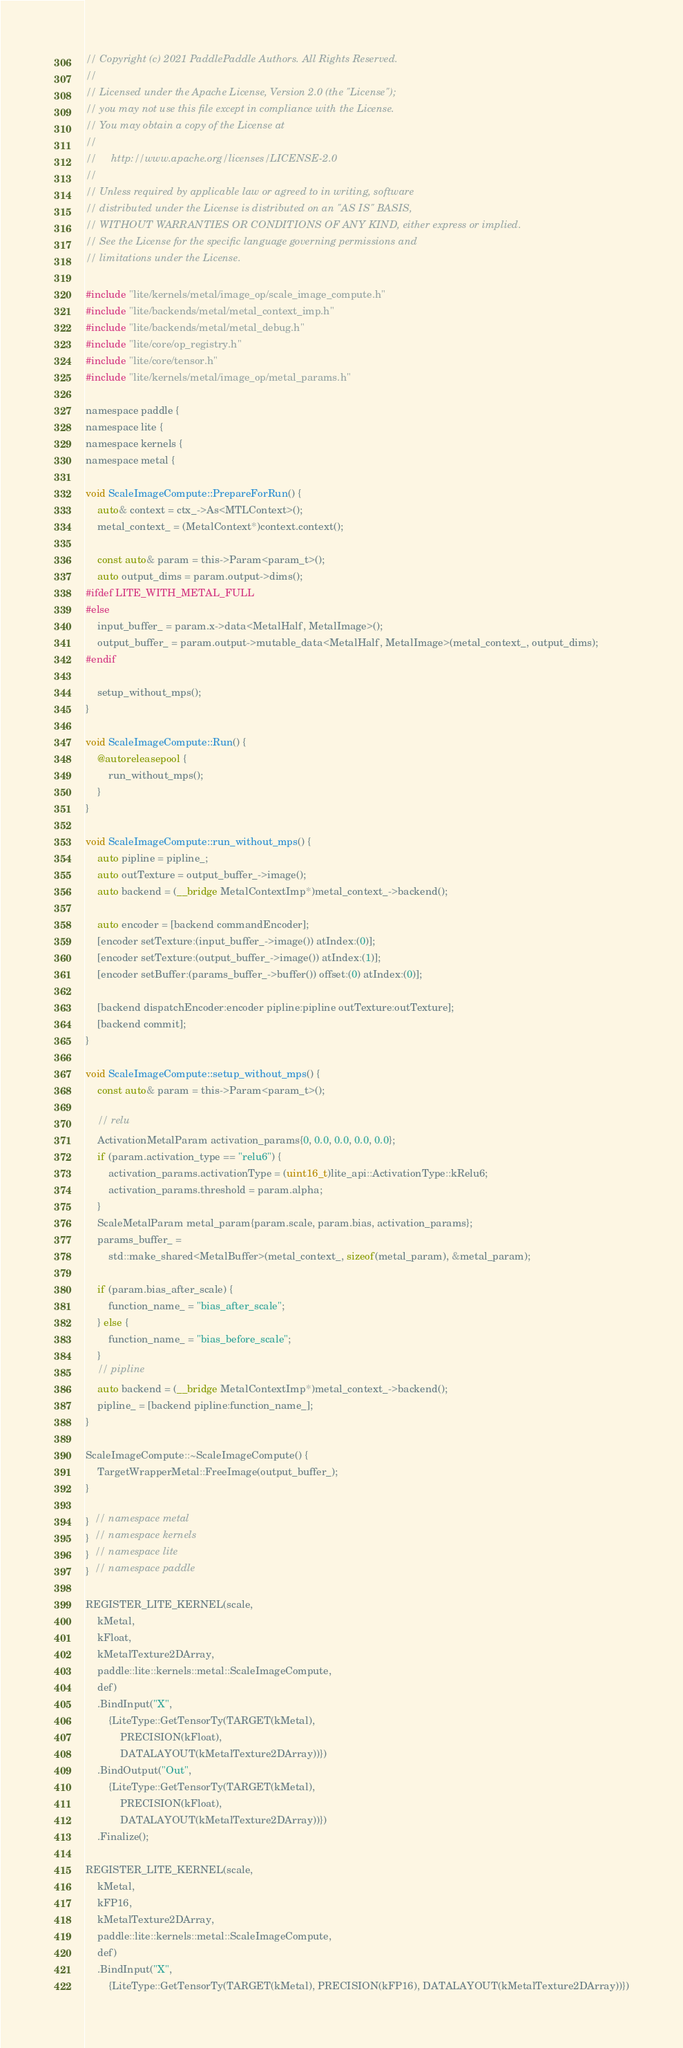Convert code to text. <code><loc_0><loc_0><loc_500><loc_500><_ObjectiveC_>// Copyright (c) 2021 PaddlePaddle Authors. All Rights Reserved.
//
// Licensed under the Apache License, Version 2.0 (the "License");
// you may not use this file except in compliance with the License.
// You may obtain a copy of the License at
//
//     http://www.apache.org/licenses/LICENSE-2.0
//
// Unless required by applicable law or agreed to in writing, software
// distributed under the License is distributed on an "AS IS" BASIS,
// WITHOUT WARRANTIES OR CONDITIONS OF ANY KIND, either express or implied.
// See the License for the specific language governing permissions and
// limitations under the License.

#include "lite/kernels/metal/image_op/scale_image_compute.h"
#include "lite/backends/metal/metal_context_imp.h"
#include "lite/backends/metal/metal_debug.h"
#include "lite/core/op_registry.h"
#include "lite/core/tensor.h"
#include "lite/kernels/metal/image_op/metal_params.h"

namespace paddle {
namespace lite {
namespace kernels {
namespace metal {

void ScaleImageCompute::PrepareForRun() {
    auto& context = ctx_->As<MTLContext>();
    metal_context_ = (MetalContext*)context.context();

    const auto& param = this->Param<param_t>();
    auto output_dims = param.output->dims();
#ifdef LITE_WITH_METAL_FULL
#else
    input_buffer_ = param.x->data<MetalHalf, MetalImage>();
    output_buffer_ = param.output->mutable_data<MetalHalf, MetalImage>(metal_context_, output_dims);
#endif

    setup_without_mps();
}

void ScaleImageCompute::Run() {
    @autoreleasepool {
        run_without_mps();
    }
}

void ScaleImageCompute::run_without_mps() {
    auto pipline = pipline_;
    auto outTexture = output_buffer_->image();
    auto backend = (__bridge MetalContextImp*)metal_context_->backend();

    auto encoder = [backend commandEncoder];
    [encoder setTexture:(input_buffer_->image()) atIndex:(0)];
    [encoder setTexture:(output_buffer_->image()) atIndex:(1)];
    [encoder setBuffer:(params_buffer_->buffer()) offset:(0) atIndex:(0)];

    [backend dispatchEncoder:encoder pipline:pipline outTexture:outTexture];
    [backend commit];
}

void ScaleImageCompute::setup_without_mps() {
    const auto& param = this->Param<param_t>();

    // relu
    ActivationMetalParam activation_params{0, 0.0, 0.0, 0.0, 0.0};
    if (param.activation_type == "relu6") {
        activation_params.activationType = (uint16_t)lite_api::ActivationType::kRelu6;
        activation_params.threshold = param.alpha;
    }
    ScaleMetalParam metal_param{param.scale, param.bias, activation_params};
    params_buffer_ =
        std::make_shared<MetalBuffer>(metal_context_, sizeof(metal_param), &metal_param);

    if (param.bias_after_scale) {
        function_name_ = "bias_after_scale";
    } else {
        function_name_ = "bias_before_scale";
    }
    // pipline
    auto backend = (__bridge MetalContextImp*)metal_context_->backend();
    pipline_ = [backend pipline:function_name_];
}

ScaleImageCompute::~ScaleImageCompute() {
    TargetWrapperMetal::FreeImage(output_buffer_);
}

}  // namespace metal
}  // namespace kernels
}  // namespace lite
}  // namespace paddle

REGISTER_LITE_KERNEL(scale,
    kMetal,
    kFloat,
    kMetalTexture2DArray,
    paddle::lite::kernels::metal::ScaleImageCompute,
    def)
    .BindInput("X",
        {LiteType::GetTensorTy(TARGET(kMetal),
            PRECISION(kFloat),
            DATALAYOUT(kMetalTexture2DArray))})
    .BindOutput("Out",
        {LiteType::GetTensorTy(TARGET(kMetal),
            PRECISION(kFloat),
            DATALAYOUT(kMetalTexture2DArray))})
    .Finalize();

REGISTER_LITE_KERNEL(scale,
    kMetal,
    kFP16,
    kMetalTexture2DArray,
    paddle::lite::kernels::metal::ScaleImageCompute,
    def)
    .BindInput("X",
        {LiteType::GetTensorTy(TARGET(kMetal), PRECISION(kFP16), DATALAYOUT(kMetalTexture2DArray))})</code> 